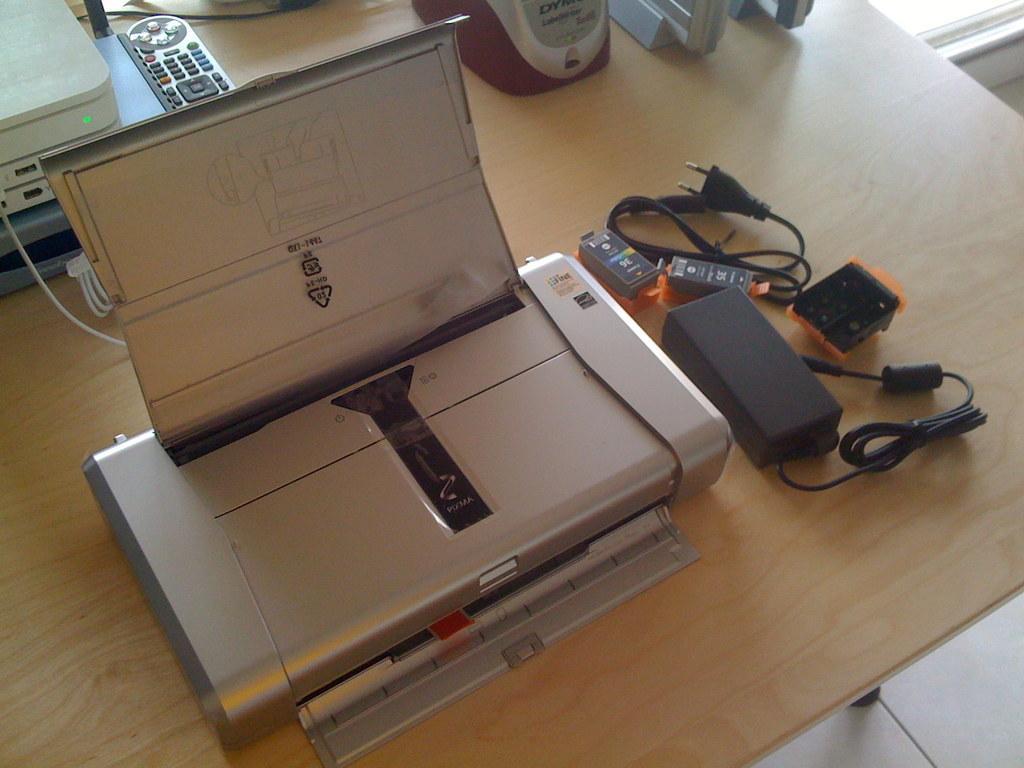Describe this image in one or two sentences. In this picture there is a printer in the center of the image and there are wires on the right side of the image and there is a remote and other electronics at the top side of the image, which are placed on a table. 